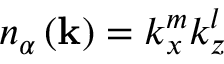Convert formula to latex. <formula><loc_0><loc_0><loc_500><loc_500>n _ { \alpha } \left ( k \right ) = k _ { x } ^ { m } k _ { z } ^ { l }</formula> 